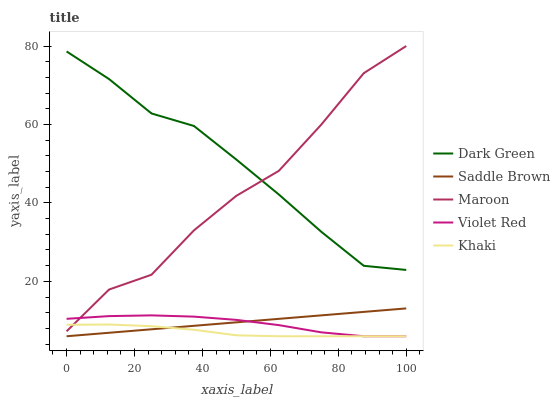Does Khaki have the minimum area under the curve?
Answer yes or no. Yes. Does Dark Green have the maximum area under the curve?
Answer yes or no. Yes. Does Saddle Brown have the minimum area under the curve?
Answer yes or no. No. Does Saddle Brown have the maximum area under the curve?
Answer yes or no. No. Is Saddle Brown the smoothest?
Answer yes or no. Yes. Is Maroon the roughest?
Answer yes or no. Yes. Is Khaki the smoothest?
Answer yes or no. No. Is Khaki the roughest?
Answer yes or no. No. Does Violet Red have the lowest value?
Answer yes or no. Yes. Does Maroon have the lowest value?
Answer yes or no. No. Does Maroon have the highest value?
Answer yes or no. Yes. Does Saddle Brown have the highest value?
Answer yes or no. No. Is Violet Red less than Dark Green?
Answer yes or no. Yes. Is Dark Green greater than Violet Red?
Answer yes or no. Yes. Does Violet Red intersect Maroon?
Answer yes or no. Yes. Is Violet Red less than Maroon?
Answer yes or no. No. Is Violet Red greater than Maroon?
Answer yes or no. No. Does Violet Red intersect Dark Green?
Answer yes or no. No. 